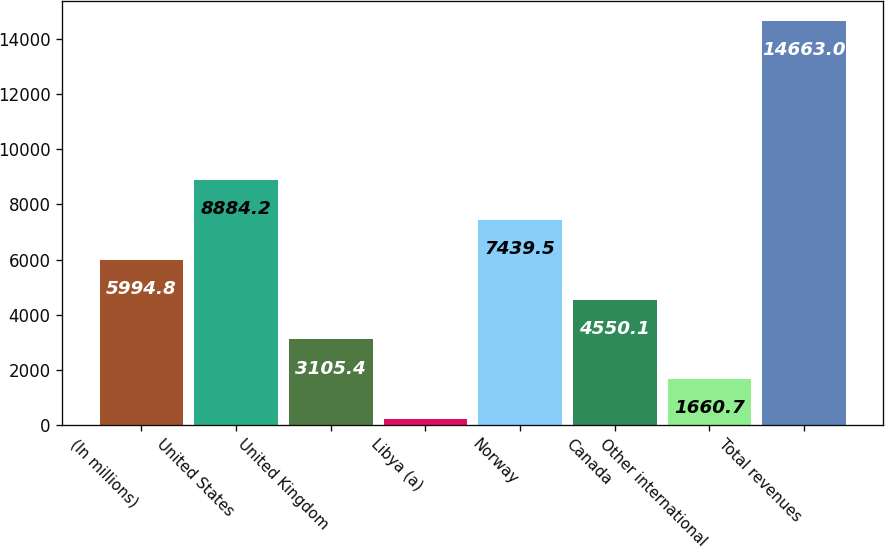Convert chart to OTSL. <chart><loc_0><loc_0><loc_500><loc_500><bar_chart><fcel>(In millions)<fcel>United States<fcel>United Kingdom<fcel>Libya (a)<fcel>Norway<fcel>Canada<fcel>Other international<fcel>Total revenues<nl><fcel>5994.8<fcel>8884.2<fcel>3105.4<fcel>216<fcel>7439.5<fcel>4550.1<fcel>1660.7<fcel>14663<nl></chart> 